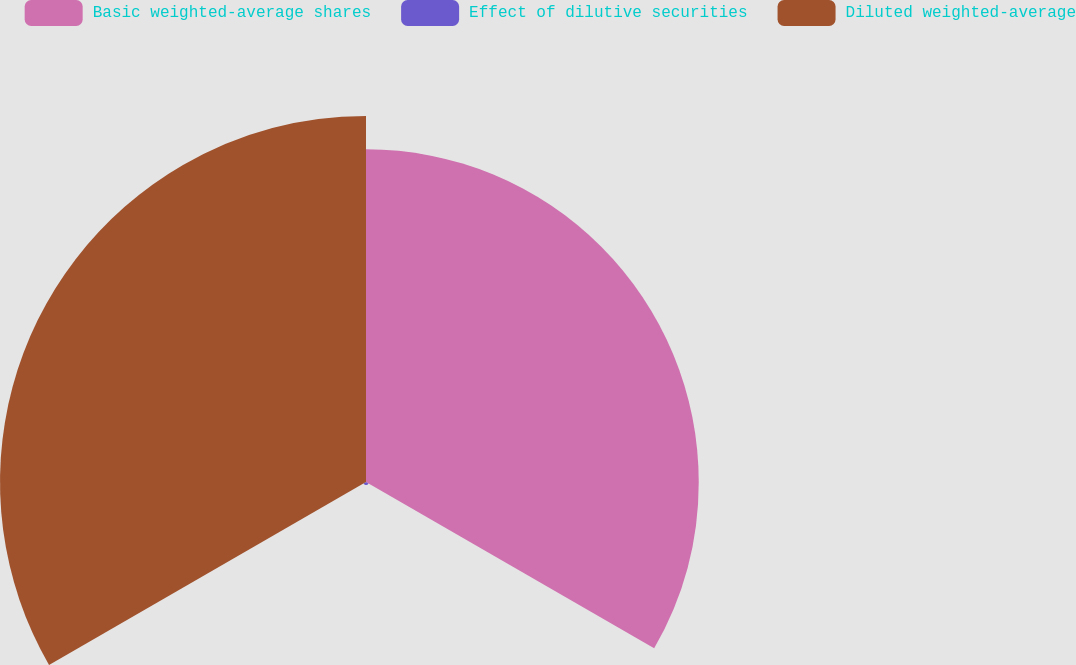Convert chart. <chart><loc_0><loc_0><loc_500><loc_500><pie_chart><fcel>Basic weighted-average shares<fcel>Effect of dilutive securities<fcel>Diluted weighted-average<nl><fcel>47.42%<fcel>0.42%<fcel>52.16%<nl></chart> 